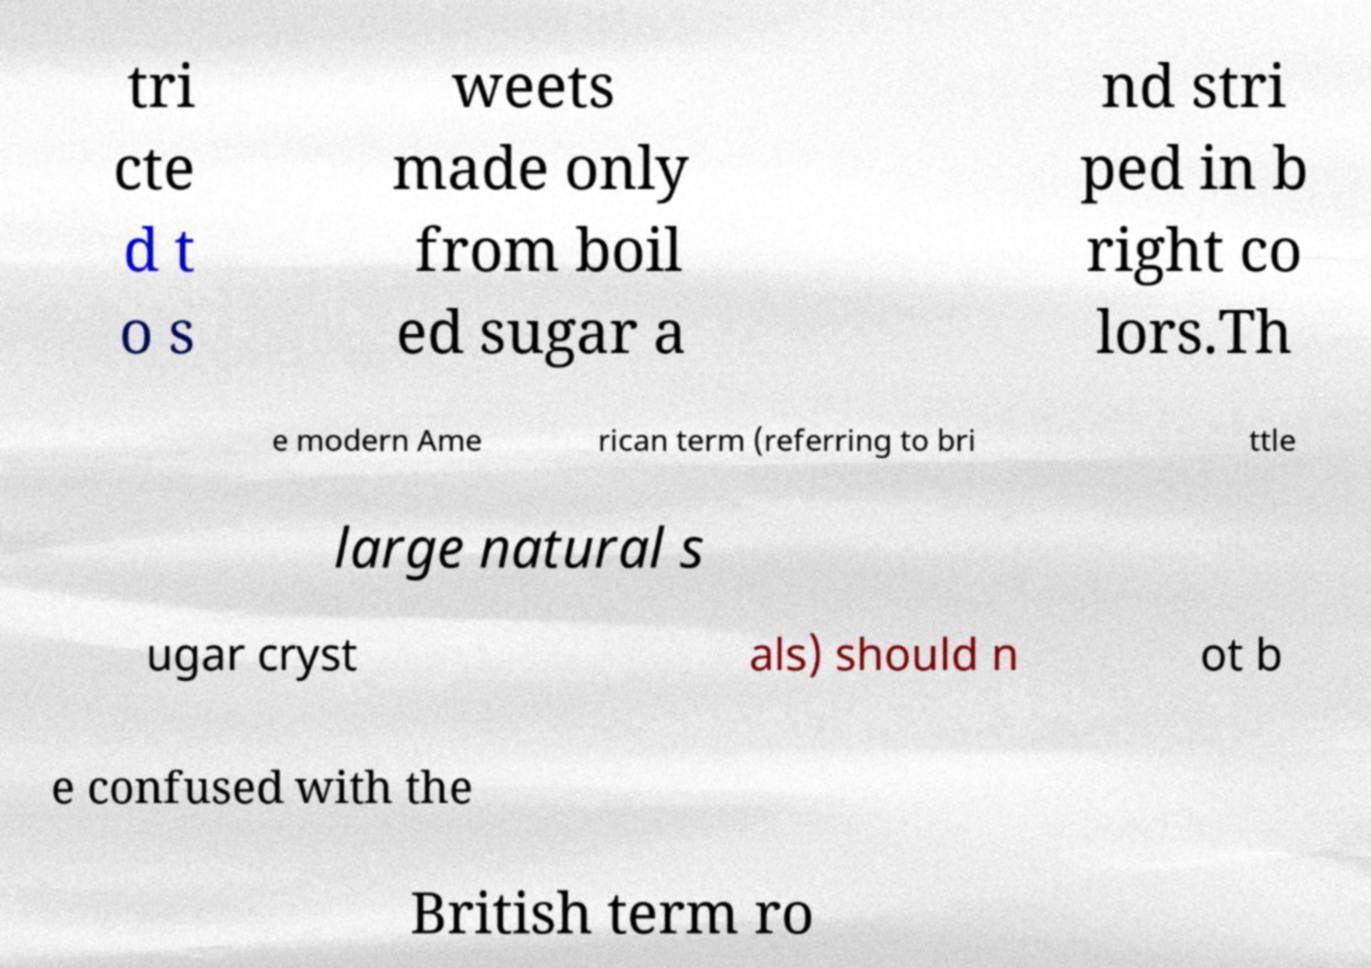There's text embedded in this image that I need extracted. Can you transcribe it verbatim? tri cte d t o s weets made only from boil ed sugar a nd stri ped in b right co lors.Th e modern Ame rican term (referring to bri ttle large natural s ugar cryst als) should n ot b e confused with the British term ro 